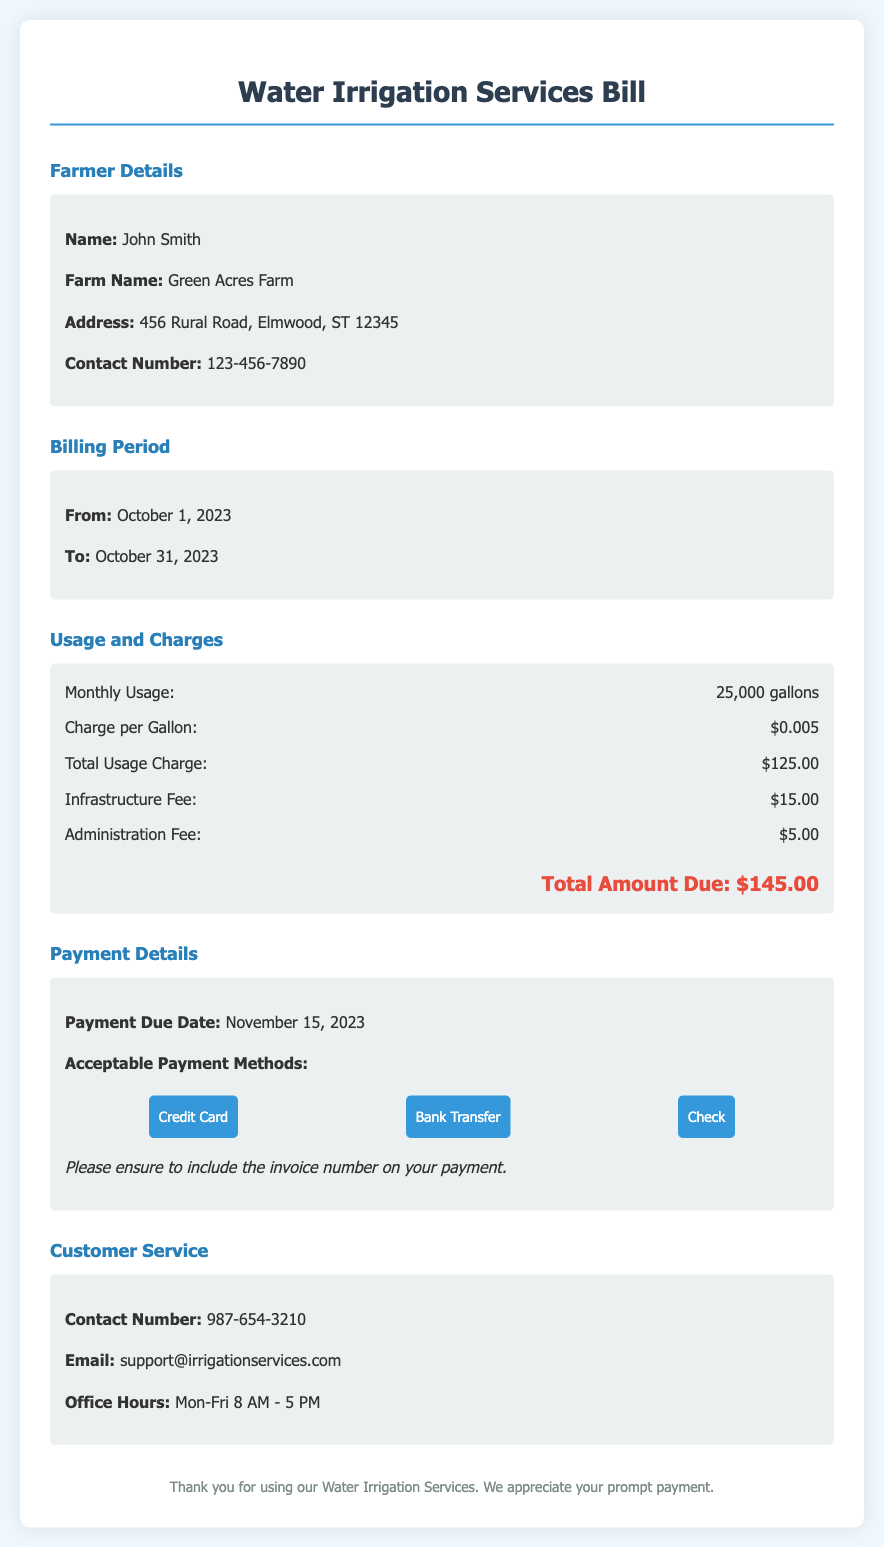What is the farmer's name? The farmer's name is listed in the details section as John Smith.
Answer: John Smith What is the billing period? The billing period is mentioned under the corresponding section as from October 1, 2023, to October 31, 2023.
Answer: October 1, 2023 to October 31, 2023 How much is the total amount due? The total amount due is provided in the charges section, which sums up different fees to be $145.00.
Answer: $145.00 What is the charge per gallon? The charge per gallon is specified in the usage and charges section as $0.005.
Answer: $0.005 When is the payment due? The payment due date is highlighted in the payment details section as November 15, 2023.
Answer: November 15, 2023 What is the total usage charge? The total usage charge is calculated based on the monthly usage and the charge per gallon, listed as $125.00.
Answer: $125.00 What fees are included in the total amount due? The total amount includes usage charge, infrastructure fee, and administration fee, totaling $145.00.
Answer: Usage charge, Infrastructure fee, Administration fee What acceptable payment methods are listed? The document specifies acceptable payment methods that include Credit Card, Bank Transfer, and Check.
Answer: Credit Card, Bank Transfer, Check What are the office hours for customer service? The office hours are stated in the customer service section as Monday to Friday from 8 AM to 5 PM.
Answer: Mon-Fri 8 AM - 5 PM 